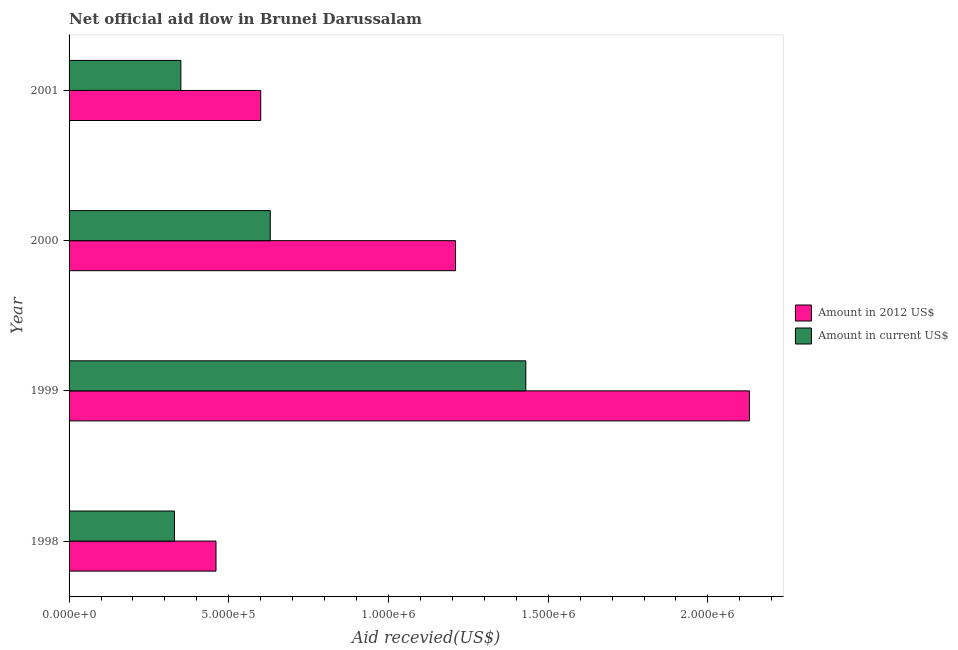Are the number of bars on each tick of the Y-axis equal?
Make the answer very short. Yes. What is the label of the 4th group of bars from the top?
Keep it short and to the point. 1998. In how many cases, is the number of bars for a given year not equal to the number of legend labels?
Provide a short and direct response. 0. What is the amount of aid received(expressed in 2012 us$) in 1998?
Offer a very short reply. 4.60e+05. Across all years, what is the maximum amount of aid received(expressed in us$)?
Make the answer very short. 1.43e+06. Across all years, what is the minimum amount of aid received(expressed in us$)?
Give a very brief answer. 3.30e+05. In which year was the amount of aid received(expressed in 2012 us$) maximum?
Offer a terse response. 1999. What is the total amount of aid received(expressed in 2012 us$) in the graph?
Give a very brief answer. 4.40e+06. What is the difference between the amount of aid received(expressed in 2012 us$) in 1999 and that in 2001?
Your answer should be very brief. 1.53e+06. What is the difference between the amount of aid received(expressed in us$) in 1999 and the amount of aid received(expressed in 2012 us$) in 2001?
Your response must be concise. 8.30e+05. What is the average amount of aid received(expressed in 2012 us$) per year?
Offer a terse response. 1.10e+06. In the year 1999, what is the difference between the amount of aid received(expressed in 2012 us$) and amount of aid received(expressed in us$)?
Provide a short and direct response. 7.00e+05. In how many years, is the amount of aid received(expressed in us$) greater than 1100000 US$?
Your answer should be compact. 1. What is the ratio of the amount of aid received(expressed in 2012 us$) in 1998 to that in 2001?
Offer a very short reply. 0.77. What is the difference between the highest and the second highest amount of aid received(expressed in 2012 us$)?
Give a very brief answer. 9.20e+05. What is the difference between the highest and the lowest amount of aid received(expressed in us$)?
Your answer should be very brief. 1.10e+06. What does the 2nd bar from the top in 2000 represents?
Provide a succinct answer. Amount in 2012 US$. What does the 1st bar from the bottom in 2001 represents?
Make the answer very short. Amount in 2012 US$. Are the values on the major ticks of X-axis written in scientific E-notation?
Keep it short and to the point. Yes. Does the graph contain any zero values?
Ensure brevity in your answer.  No. Where does the legend appear in the graph?
Give a very brief answer. Center right. What is the title of the graph?
Offer a very short reply. Net official aid flow in Brunei Darussalam. What is the label or title of the X-axis?
Make the answer very short. Aid recevied(US$). What is the label or title of the Y-axis?
Offer a very short reply. Year. What is the Aid recevied(US$) in Amount in 2012 US$ in 1999?
Your answer should be compact. 2.13e+06. What is the Aid recevied(US$) of Amount in current US$ in 1999?
Your answer should be compact. 1.43e+06. What is the Aid recevied(US$) in Amount in 2012 US$ in 2000?
Your answer should be very brief. 1.21e+06. What is the Aid recevied(US$) in Amount in current US$ in 2000?
Give a very brief answer. 6.30e+05. What is the Aid recevied(US$) in Amount in 2012 US$ in 2001?
Your answer should be very brief. 6.00e+05. What is the Aid recevied(US$) in Amount in current US$ in 2001?
Offer a terse response. 3.50e+05. Across all years, what is the maximum Aid recevied(US$) of Amount in 2012 US$?
Keep it short and to the point. 2.13e+06. Across all years, what is the maximum Aid recevied(US$) of Amount in current US$?
Give a very brief answer. 1.43e+06. Across all years, what is the minimum Aid recevied(US$) in Amount in current US$?
Offer a terse response. 3.30e+05. What is the total Aid recevied(US$) in Amount in 2012 US$ in the graph?
Offer a very short reply. 4.40e+06. What is the total Aid recevied(US$) of Amount in current US$ in the graph?
Your response must be concise. 2.74e+06. What is the difference between the Aid recevied(US$) in Amount in 2012 US$ in 1998 and that in 1999?
Your response must be concise. -1.67e+06. What is the difference between the Aid recevied(US$) in Amount in current US$ in 1998 and that in 1999?
Keep it short and to the point. -1.10e+06. What is the difference between the Aid recevied(US$) in Amount in 2012 US$ in 1998 and that in 2000?
Offer a very short reply. -7.50e+05. What is the difference between the Aid recevied(US$) of Amount in 2012 US$ in 1998 and that in 2001?
Your answer should be very brief. -1.40e+05. What is the difference between the Aid recevied(US$) of Amount in 2012 US$ in 1999 and that in 2000?
Provide a succinct answer. 9.20e+05. What is the difference between the Aid recevied(US$) of Amount in current US$ in 1999 and that in 2000?
Make the answer very short. 8.00e+05. What is the difference between the Aid recevied(US$) of Amount in 2012 US$ in 1999 and that in 2001?
Ensure brevity in your answer.  1.53e+06. What is the difference between the Aid recevied(US$) in Amount in current US$ in 1999 and that in 2001?
Ensure brevity in your answer.  1.08e+06. What is the difference between the Aid recevied(US$) in Amount in 2012 US$ in 1998 and the Aid recevied(US$) in Amount in current US$ in 1999?
Offer a terse response. -9.70e+05. What is the difference between the Aid recevied(US$) in Amount in 2012 US$ in 1998 and the Aid recevied(US$) in Amount in current US$ in 2000?
Keep it short and to the point. -1.70e+05. What is the difference between the Aid recevied(US$) of Amount in 2012 US$ in 1999 and the Aid recevied(US$) of Amount in current US$ in 2000?
Your answer should be very brief. 1.50e+06. What is the difference between the Aid recevied(US$) in Amount in 2012 US$ in 1999 and the Aid recevied(US$) in Amount in current US$ in 2001?
Offer a terse response. 1.78e+06. What is the difference between the Aid recevied(US$) in Amount in 2012 US$ in 2000 and the Aid recevied(US$) in Amount in current US$ in 2001?
Ensure brevity in your answer.  8.60e+05. What is the average Aid recevied(US$) in Amount in 2012 US$ per year?
Keep it short and to the point. 1.10e+06. What is the average Aid recevied(US$) in Amount in current US$ per year?
Ensure brevity in your answer.  6.85e+05. In the year 1998, what is the difference between the Aid recevied(US$) in Amount in 2012 US$ and Aid recevied(US$) in Amount in current US$?
Give a very brief answer. 1.30e+05. In the year 1999, what is the difference between the Aid recevied(US$) in Amount in 2012 US$ and Aid recevied(US$) in Amount in current US$?
Offer a very short reply. 7.00e+05. In the year 2000, what is the difference between the Aid recevied(US$) in Amount in 2012 US$ and Aid recevied(US$) in Amount in current US$?
Provide a succinct answer. 5.80e+05. In the year 2001, what is the difference between the Aid recevied(US$) of Amount in 2012 US$ and Aid recevied(US$) of Amount in current US$?
Offer a very short reply. 2.50e+05. What is the ratio of the Aid recevied(US$) in Amount in 2012 US$ in 1998 to that in 1999?
Provide a short and direct response. 0.22. What is the ratio of the Aid recevied(US$) of Amount in current US$ in 1998 to that in 1999?
Keep it short and to the point. 0.23. What is the ratio of the Aid recevied(US$) of Amount in 2012 US$ in 1998 to that in 2000?
Provide a short and direct response. 0.38. What is the ratio of the Aid recevied(US$) of Amount in current US$ in 1998 to that in 2000?
Your answer should be compact. 0.52. What is the ratio of the Aid recevied(US$) of Amount in 2012 US$ in 1998 to that in 2001?
Your answer should be compact. 0.77. What is the ratio of the Aid recevied(US$) of Amount in current US$ in 1998 to that in 2001?
Keep it short and to the point. 0.94. What is the ratio of the Aid recevied(US$) in Amount in 2012 US$ in 1999 to that in 2000?
Give a very brief answer. 1.76. What is the ratio of the Aid recevied(US$) of Amount in current US$ in 1999 to that in 2000?
Your response must be concise. 2.27. What is the ratio of the Aid recevied(US$) in Amount in 2012 US$ in 1999 to that in 2001?
Your answer should be very brief. 3.55. What is the ratio of the Aid recevied(US$) of Amount in current US$ in 1999 to that in 2001?
Make the answer very short. 4.09. What is the ratio of the Aid recevied(US$) of Amount in 2012 US$ in 2000 to that in 2001?
Make the answer very short. 2.02. What is the ratio of the Aid recevied(US$) of Amount in current US$ in 2000 to that in 2001?
Your answer should be very brief. 1.8. What is the difference between the highest and the second highest Aid recevied(US$) of Amount in 2012 US$?
Keep it short and to the point. 9.20e+05. What is the difference between the highest and the second highest Aid recevied(US$) of Amount in current US$?
Provide a succinct answer. 8.00e+05. What is the difference between the highest and the lowest Aid recevied(US$) in Amount in 2012 US$?
Make the answer very short. 1.67e+06. What is the difference between the highest and the lowest Aid recevied(US$) in Amount in current US$?
Offer a very short reply. 1.10e+06. 